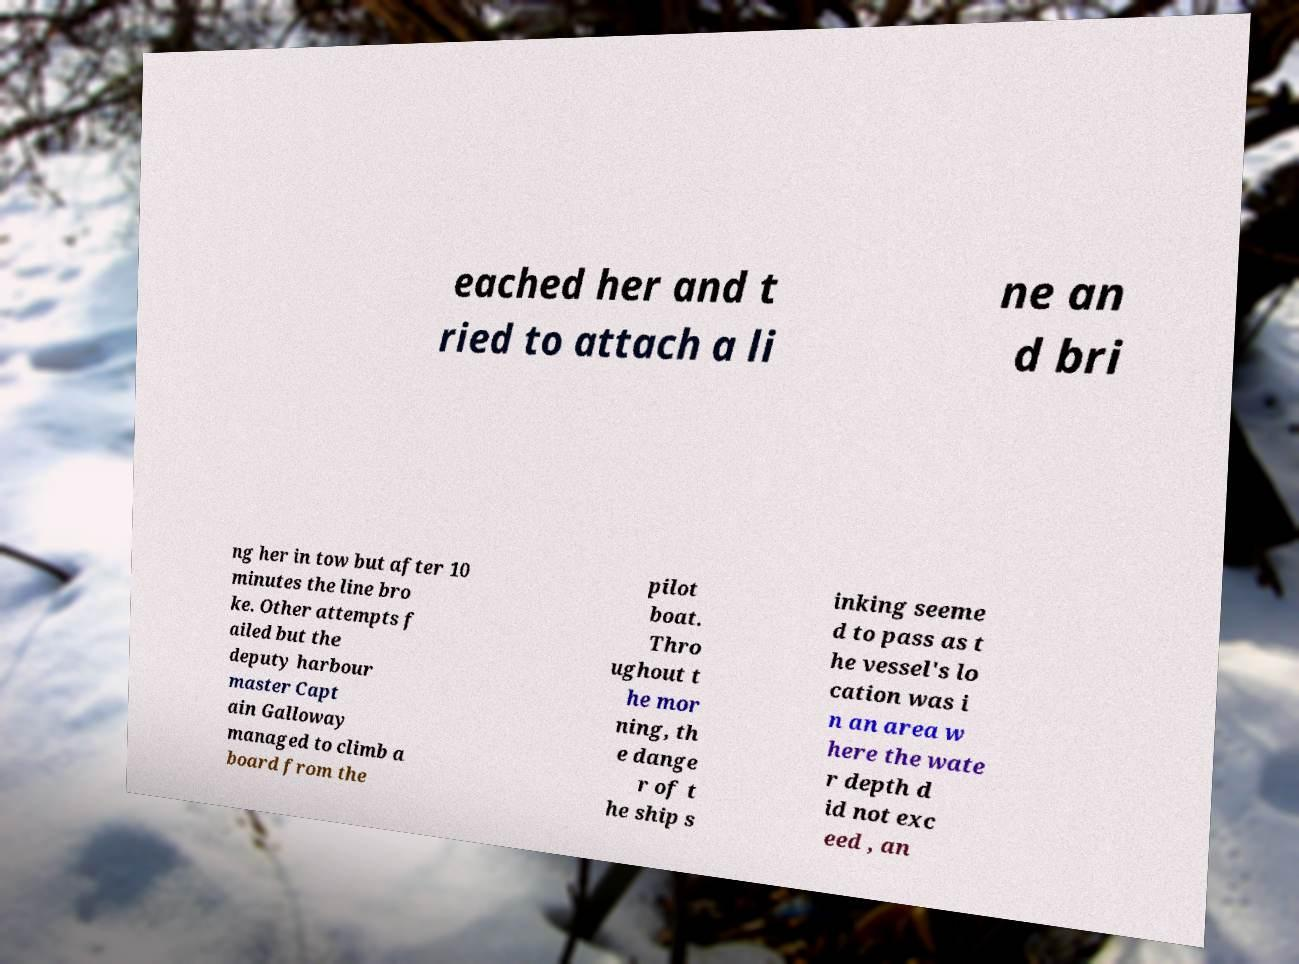There's text embedded in this image that I need extracted. Can you transcribe it verbatim? eached her and t ried to attach a li ne an d bri ng her in tow but after 10 minutes the line bro ke. Other attempts f ailed but the deputy harbour master Capt ain Galloway managed to climb a board from the pilot boat. Thro ughout t he mor ning, th e dange r of t he ship s inking seeme d to pass as t he vessel's lo cation was i n an area w here the wate r depth d id not exc eed , an 